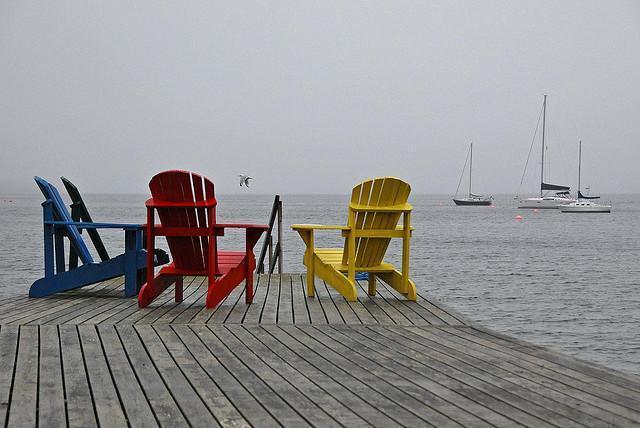How many chairs are there?
Give a very brief answer. 3. How many people are jumping in the air?
Give a very brief answer. 0. 